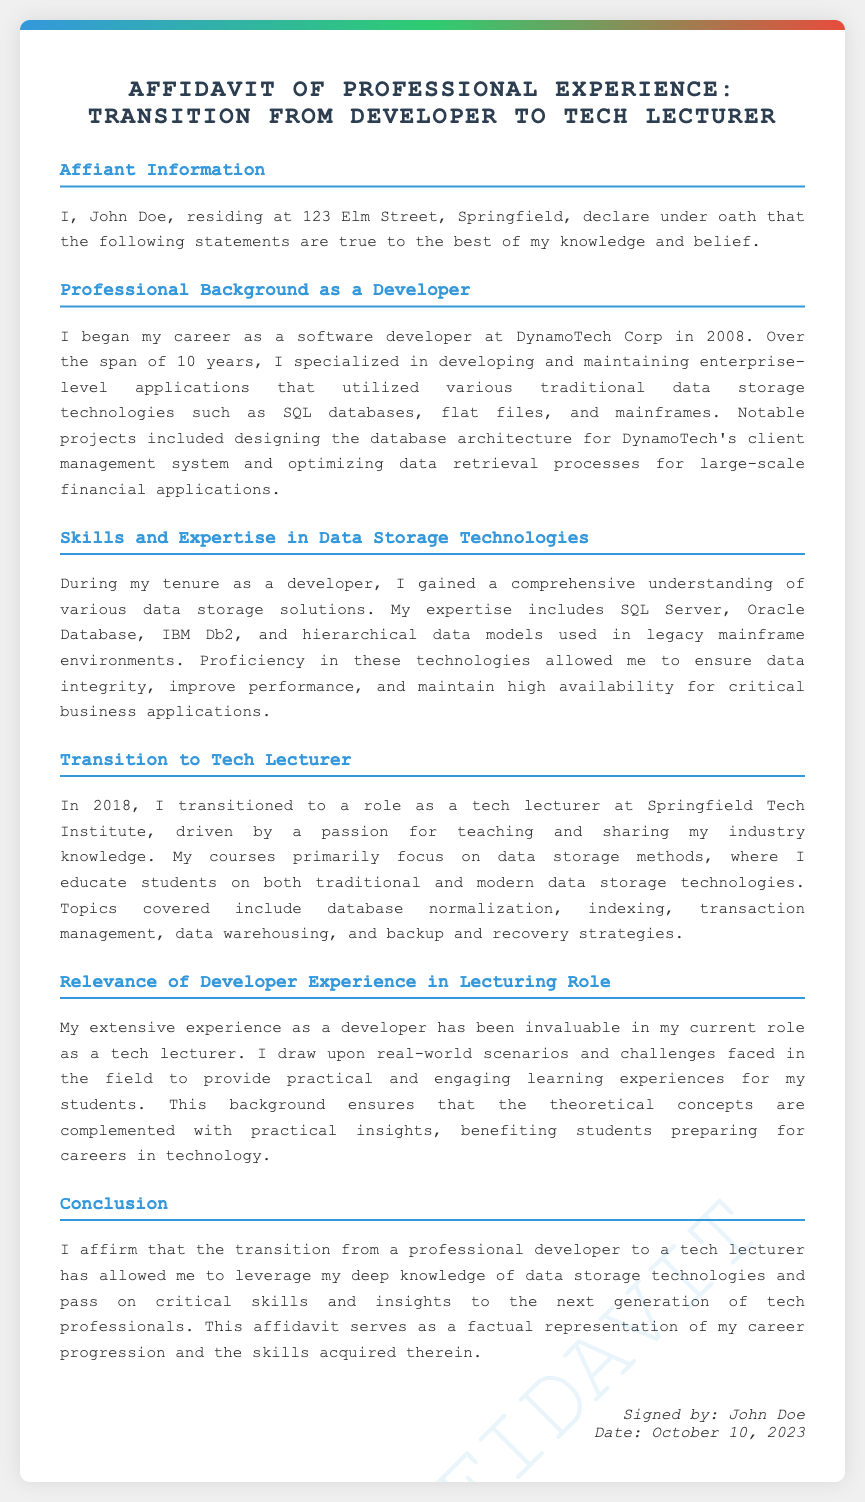what is the name of the affiant? The affiant is referred to as John Doe in the document.
Answer: John Doe what year did the affiant begin his career? The document states that the affiant began his career in 2008.
Answer: 2008 how many years did the affiant work as a developer? The document mentions a span of 10 years working as a developer.
Answer: 10 years in which year did the affiant transition to a tech lecturer? According to the document, the affiant transitioned to this role in 2018.
Answer: 2018 what is the primary focus of the courses taught by the affiant? The document indicates that the primary focus is on data storage methods.
Answer: data storage methods which company did the affiant work for as a developer? The document specifies that the affiant worked for DynamoTech Corp.
Answer: DynamoTech Corp what types of data storage technologies does the affiant have expertise in? The document lists SQL Server, Oracle Database, IBM Db2, and hierarchical data models.
Answer: SQL Server, Oracle Database, IBM Db2, hierarchical data models how does the affiant describe the relevance of his developer experience in lecturing? The document states that the experience provides practical insights and benefits students.
Answer: practical insights and benefits students what is the date inscribed on the affidavit? The document specifies that the date is October 10, 2023.
Answer: October 10, 2023 